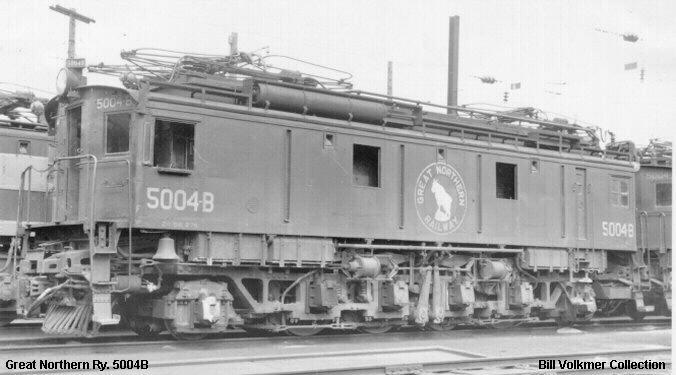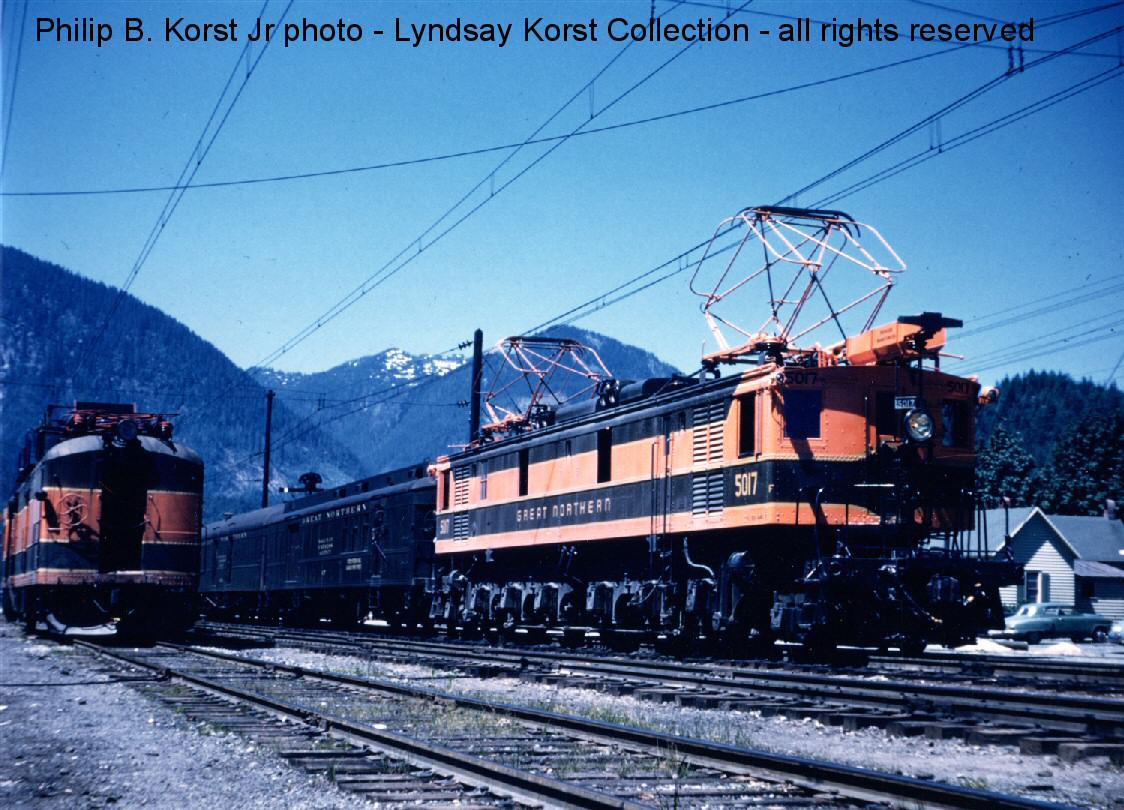The first image is the image on the left, the second image is the image on the right. For the images shown, is this caption "Each train is run by a cable railway." true? Answer yes or no. Yes. The first image is the image on the left, the second image is the image on the right. For the images shown, is this caption "In one vintage image, the engineer is visible through the window of a train heading rightward." true? Answer yes or no. No. 